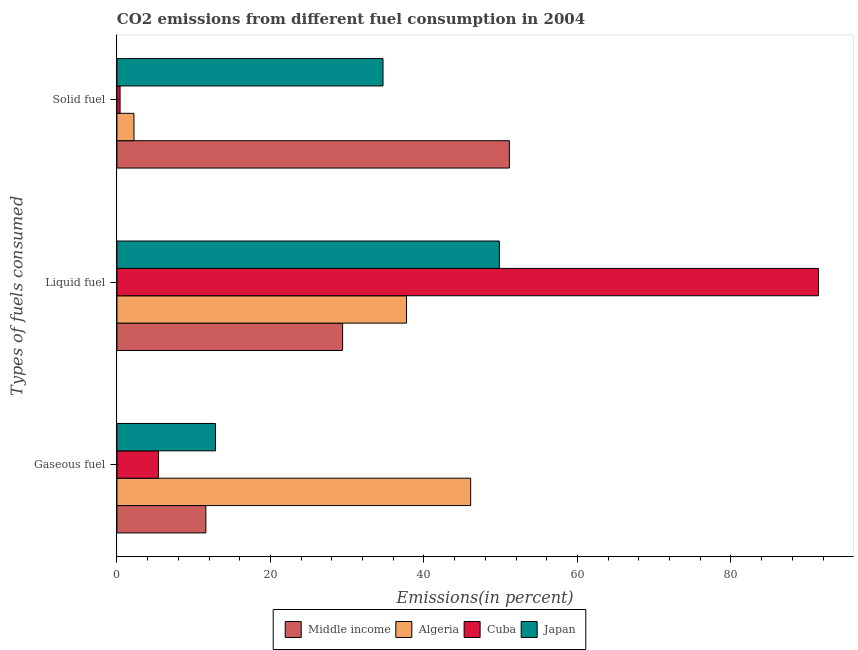How many different coloured bars are there?
Your response must be concise. 4. How many groups of bars are there?
Provide a succinct answer. 3. Are the number of bars per tick equal to the number of legend labels?
Provide a succinct answer. Yes. What is the label of the 3rd group of bars from the top?
Offer a very short reply. Gaseous fuel. What is the percentage of gaseous fuel emission in Cuba?
Offer a terse response. 5.41. Across all countries, what is the maximum percentage of solid fuel emission?
Your answer should be compact. 51.13. Across all countries, what is the minimum percentage of liquid fuel emission?
Your answer should be compact. 29.4. In which country was the percentage of solid fuel emission minimum?
Provide a succinct answer. Cuba. What is the total percentage of gaseous fuel emission in the graph?
Your answer should be very brief. 75.92. What is the difference between the percentage of gaseous fuel emission in Cuba and that in Japan?
Offer a terse response. -7.43. What is the difference between the percentage of liquid fuel emission in Middle income and the percentage of gaseous fuel emission in Japan?
Make the answer very short. 16.56. What is the average percentage of gaseous fuel emission per country?
Offer a very short reply. 18.98. What is the difference between the percentage of gaseous fuel emission and percentage of solid fuel emission in Cuba?
Give a very brief answer. 5. What is the ratio of the percentage of solid fuel emission in Japan to that in Algeria?
Offer a terse response. 15.61. What is the difference between the highest and the second highest percentage of solid fuel emission?
Provide a short and direct response. 16.46. What is the difference between the highest and the lowest percentage of liquid fuel emission?
Keep it short and to the point. 61.99. What does the 2nd bar from the top in Gaseous fuel represents?
Provide a succinct answer. Cuba. What does the 2nd bar from the bottom in Solid fuel represents?
Ensure brevity in your answer.  Algeria. Are all the bars in the graph horizontal?
Give a very brief answer. Yes. Are the values on the major ticks of X-axis written in scientific E-notation?
Make the answer very short. No. How are the legend labels stacked?
Ensure brevity in your answer.  Horizontal. What is the title of the graph?
Offer a very short reply. CO2 emissions from different fuel consumption in 2004. Does "Greenland" appear as one of the legend labels in the graph?
Provide a short and direct response. No. What is the label or title of the X-axis?
Provide a succinct answer. Emissions(in percent). What is the label or title of the Y-axis?
Ensure brevity in your answer.  Types of fuels consumed. What is the Emissions(in percent) in Middle income in Gaseous fuel?
Give a very brief answer. 11.59. What is the Emissions(in percent) of Algeria in Gaseous fuel?
Provide a succinct answer. 46.08. What is the Emissions(in percent) in Cuba in Gaseous fuel?
Give a very brief answer. 5.41. What is the Emissions(in percent) of Japan in Gaseous fuel?
Keep it short and to the point. 12.84. What is the Emissions(in percent) of Middle income in Liquid fuel?
Provide a succinct answer. 29.4. What is the Emissions(in percent) in Algeria in Liquid fuel?
Your response must be concise. 37.73. What is the Emissions(in percent) in Cuba in Liquid fuel?
Keep it short and to the point. 91.39. What is the Emissions(in percent) in Japan in Liquid fuel?
Your response must be concise. 49.83. What is the Emissions(in percent) of Middle income in Solid fuel?
Offer a terse response. 51.13. What is the Emissions(in percent) in Algeria in Solid fuel?
Ensure brevity in your answer.  2.22. What is the Emissions(in percent) of Cuba in Solid fuel?
Offer a terse response. 0.41. What is the Emissions(in percent) in Japan in Solid fuel?
Ensure brevity in your answer.  34.67. Across all Types of fuels consumed, what is the maximum Emissions(in percent) of Middle income?
Ensure brevity in your answer.  51.13. Across all Types of fuels consumed, what is the maximum Emissions(in percent) in Algeria?
Provide a succinct answer. 46.08. Across all Types of fuels consumed, what is the maximum Emissions(in percent) in Cuba?
Offer a terse response. 91.39. Across all Types of fuels consumed, what is the maximum Emissions(in percent) in Japan?
Make the answer very short. 49.83. Across all Types of fuels consumed, what is the minimum Emissions(in percent) of Middle income?
Ensure brevity in your answer.  11.59. Across all Types of fuels consumed, what is the minimum Emissions(in percent) of Algeria?
Your response must be concise. 2.22. Across all Types of fuels consumed, what is the minimum Emissions(in percent) of Cuba?
Offer a very short reply. 0.41. Across all Types of fuels consumed, what is the minimum Emissions(in percent) of Japan?
Ensure brevity in your answer.  12.84. What is the total Emissions(in percent) in Middle income in the graph?
Your answer should be very brief. 92.12. What is the total Emissions(in percent) in Algeria in the graph?
Provide a short and direct response. 86.04. What is the total Emissions(in percent) of Cuba in the graph?
Make the answer very short. 97.21. What is the total Emissions(in percent) in Japan in the graph?
Give a very brief answer. 97.33. What is the difference between the Emissions(in percent) of Middle income in Gaseous fuel and that in Liquid fuel?
Keep it short and to the point. -17.82. What is the difference between the Emissions(in percent) of Algeria in Gaseous fuel and that in Liquid fuel?
Ensure brevity in your answer.  8.35. What is the difference between the Emissions(in percent) of Cuba in Gaseous fuel and that in Liquid fuel?
Give a very brief answer. -85.98. What is the difference between the Emissions(in percent) of Japan in Gaseous fuel and that in Liquid fuel?
Make the answer very short. -36.99. What is the difference between the Emissions(in percent) of Middle income in Gaseous fuel and that in Solid fuel?
Offer a very short reply. -39.54. What is the difference between the Emissions(in percent) in Algeria in Gaseous fuel and that in Solid fuel?
Your response must be concise. 43.86. What is the difference between the Emissions(in percent) of Cuba in Gaseous fuel and that in Solid fuel?
Your answer should be very brief. 5. What is the difference between the Emissions(in percent) of Japan in Gaseous fuel and that in Solid fuel?
Your response must be concise. -21.83. What is the difference between the Emissions(in percent) of Middle income in Liquid fuel and that in Solid fuel?
Give a very brief answer. -21.72. What is the difference between the Emissions(in percent) of Algeria in Liquid fuel and that in Solid fuel?
Ensure brevity in your answer.  35.51. What is the difference between the Emissions(in percent) of Cuba in Liquid fuel and that in Solid fuel?
Make the answer very short. 90.98. What is the difference between the Emissions(in percent) of Japan in Liquid fuel and that in Solid fuel?
Your answer should be compact. 15.16. What is the difference between the Emissions(in percent) of Middle income in Gaseous fuel and the Emissions(in percent) of Algeria in Liquid fuel?
Your answer should be very brief. -26.14. What is the difference between the Emissions(in percent) of Middle income in Gaseous fuel and the Emissions(in percent) of Cuba in Liquid fuel?
Your answer should be very brief. -79.8. What is the difference between the Emissions(in percent) in Middle income in Gaseous fuel and the Emissions(in percent) in Japan in Liquid fuel?
Your response must be concise. -38.24. What is the difference between the Emissions(in percent) of Algeria in Gaseous fuel and the Emissions(in percent) of Cuba in Liquid fuel?
Your response must be concise. -45.31. What is the difference between the Emissions(in percent) of Algeria in Gaseous fuel and the Emissions(in percent) of Japan in Liquid fuel?
Make the answer very short. -3.74. What is the difference between the Emissions(in percent) in Cuba in Gaseous fuel and the Emissions(in percent) in Japan in Liquid fuel?
Ensure brevity in your answer.  -44.41. What is the difference between the Emissions(in percent) of Middle income in Gaseous fuel and the Emissions(in percent) of Algeria in Solid fuel?
Provide a succinct answer. 9.37. What is the difference between the Emissions(in percent) in Middle income in Gaseous fuel and the Emissions(in percent) in Cuba in Solid fuel?
Offer a terse response. 11.18. What is the difference between the Emissions(in percent) in Middle income in Gaseous fuel and the Emissions(in percent) in Japan in Solid fuel?
Your answer should be compact. -23.08. What is the difference between the Emissions(in percent) in Algeria in Gaseous fuel and the Emissions(in percent) in Cuba in Solid fuel?
Give a very brief answer. 45.67. What is the difference between the Emissions(in percent) in Algeria in Gaseous fuel and the Emissions(in percent) in Japan in Solid fuel?
Make the answer very short. 11.42. What is the difference between the Emissions(in percent) of Cuba in Gaseous fuel and the Emissions(in percent) of Japan in Solid fuel?
Ensure brevity in your answer.  -29.26. What is the difference between the Emissions(in percent) in Middle income in Liquid fuel and the Emissions(in percent) in Algeria in Solid fuel?
Ensure brevity in your answer.  27.18. What is the difference between the Emissions(in percent) in Middle income in Liquid fuel and the Emissions(in percent) in Cuba in Solid fuel?
Provide a succinct answer. 28.99. What is the difference between the Emissions(in percent) of Middle income in Liquid fuel and the Emissions(in percent) of Japan in Solid fuel?
Your answer should be compact. -5.26. What is the difference between the Emissions(in percent) in Algeria in Liquid fuel and the Emissions(in percent) in Cuba in Solid fuel?
Give a very brief answer. 37.32. What is the difference between the Emissions(in percent) in Algeria in Liquid fuel and the Emissions(in percent) in Japan in Solid fuel?
Make the answer very short. 3.06. What is the difference between the Emissions(in percent) in Cuba in Liquid fuel and the Emissions(in percent) in Japan in Solid fuel?
Ensure brevity in your answer.  56.72. What is the average Emissions(in percent) of Middle income per Types of fuels consumed?
Make the answer very short. 30.71. What is the average Emissions(in percent) in Algeria per Types of fuels consumed?
Provide a succinct answer. 28.68. What is the average Emissions(in percent) in Cuba per Types of fuels consumed?
Offer a terse response. 32.4. What is the average Emissions(in percent) in Japan per Types of fuels consumed?
Give a very brief answer. 32.44. What is the difference between the Emissions(in percent) in Middle income and Emissions(in percent) in Algeria in Gaseous fuel?
Offer a terse response. -34.5. What is the difference between the Emissions(in percent) of Middle income and Emissions(in percent) of Cuba in Gaseous fuel?
Provide a short and direct response. 6.18. What is the difference between the Emissions(in percent) in Middle income and Emissions(in percent) in Japan in Gaseous fuel?
Ensure brevity in your answer.  -1.25. What is the difference between the Emissions(in percent) in Algeria and Emissions(in percent) in Cuba in Gaseous fuel?
Provide a short and direct response. 40.67. What is the difference between the Emissions(in percent) in Algeria and Emissions(in percent) in Japan in Gaseous fuel?
Provide a short and direct response. 33.25. What is the difference between the Emissions(in percent) in Cuba and Emissions(in percent) in Japan in Gaseous fuel?
Provide a short and direct response. -7.43. What is the difference between the Emissions(in percent) in Middle income and Emissions(in percent) in Algeria in Liquid fuel?
Offer a terse response. -8.33. What is the difference between the Emissions(in percent) of Middle income and Emissions(in percent) of Cuba in Liquid fuel?
Make the answer very short. -61.99. What is the difference between the Emissions(in percent) of Middle income and Emissions(in percent) of Japan in Liquid fuel?
Offer a terse response. -20.42. What is the difference between the Emissions(in percent) of Algeria and Emissions(in percent) of Cuba in Liquid fuel?
Your answer should be compact. -53.66. What is the difference between the Emissions(in percent) of Algeria and Emissions(in percent) of Japan in Liquid fuel?
Make the answer very short. -12.1. What is the difference between the Emissions(in percent) of Cuba and Emissions(in percent) of Japan in Liquid fuel?
Offer a very short reply. 41.57. What is the difference between the Emissions(in percent) in Middle income and Emissions(in percent) in Algeria in Solid fuel?
Provide a short and direct response. 48.91. What is the difference between the Emissions(in percent) in Middle income and Emissions(in percent) in Cuba in Solid fuel?
Give a very brief answer. 50.72. What is the difference between the Emissions(in percent) of Middle income and Emissions(in percent) of Japan in Solid fuel?
Ensure brevity in your answer.  16.46. What is the difference between the Emissions(in percent) in Algeria and Emissions(in percent) in Cuba in Solid fuel?
Give a very brief answer. 1.81. What is the difference between the Emissions(in percent) in Algeria and Emissions(in percent) in Japan in Solid fuel?
Give a very brief answer. -32.45. What is the difference between the Emissions(in percent) of Cuba and Emissions(in percent) of Japan in Solid fuel?
Your response must be concise. -34.26. What is the ratio of the Emissions(in percent) in Middle income in Gaseous fuel to that in Liquid fuel?
Your response must be concise. 0.39. What is the ratio of the Emissions(in percent) in Algeria in Gaseous fuel to that in Liquid fuel?
Give a very brief answer. 1.22. What is the ratio of the Emissions(in percent) in Cuba in Gaseous fuel to that in Liquid fuel?
Offer a terse response. 0.06. What is the ratio of the Emissions(in percent) in Japan in Gaseous fuel to that in Liquid fuel?
Give a very brief answer. 0.26. What is the ratio of the Emissions(in percent) of Middle income in Gaseous fuel to that in Solid fuel?
Provide a succinct answer. 0.23. What is the ratio of the Emissions(in percent) of Algeria in Gaseous fuel to that in Solid fuel?
Your answer should be very brief. 20.75. What is the ratio of the Emissions(in percent) in Cuba in Gaseous fuel to that in Solid fuel?
Make the answer very short. 13.18. What is the ratio of the Emissions(in percent) of Japan in Gaseous fuel to that in Solid fuel?
Your answer should be compact. 0.37. What is the ratio of the Emissions(in percent) of Middle income in Liquid fuel to that in Solid fuel?
Ensure brevity in your answer.  0.58. What is the ratio of the Emissions(in percent) of Algeria in Liquid fuel to that in Solid fuel?
Offer a very short reply. 16.99. What is the ratio of the Emissions(in percent) in Cuba in Liquid fuel to that in Solid fuel?
Keep it short and to the point. 222.57. What is the ratio of the Emissions(in percent) in Japan in Liquid fuel to that in Solid fuel?
Keep it short and to the point. 1.44. What is the difference between the highest and the second highest Emissions(in percent) of Middle income?
Offer a terse response. 21.72. What is the difference between the highest and the second highest Emissions(in percent) in Algeria?
Provide a succinct answer. 8.35. What is the difference between the highest and the second highest Emissions(in percent) of Cuba?
Ensure brevity in your answer.  85.98. What is the difference between the highest and the second highest Emissions(in percent) of Japan?
Keep it short and to the point. 15.16. What is the difference between the highest and the lowest Emissions(in percent) in Middle income?
Give a very brief answer. 39.54. What is the difference between the highest and the lowest Emissions(in percent) in Algeria?
Make the answer very short. 43.86. What is the difference between the highest and the lowest Emissions(in percent) of Cuba?
Make the answer very short. 90.98. What is the difference between the highest and the lowest Emissions(in percent) in Japan?
Offer a very short reply. 36.99. 